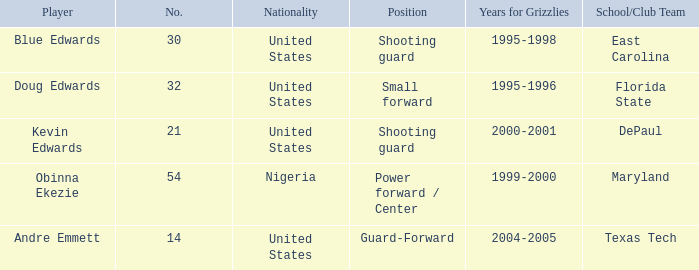Which educational institution/club squad did blue edwards participate in? East Carolina. 